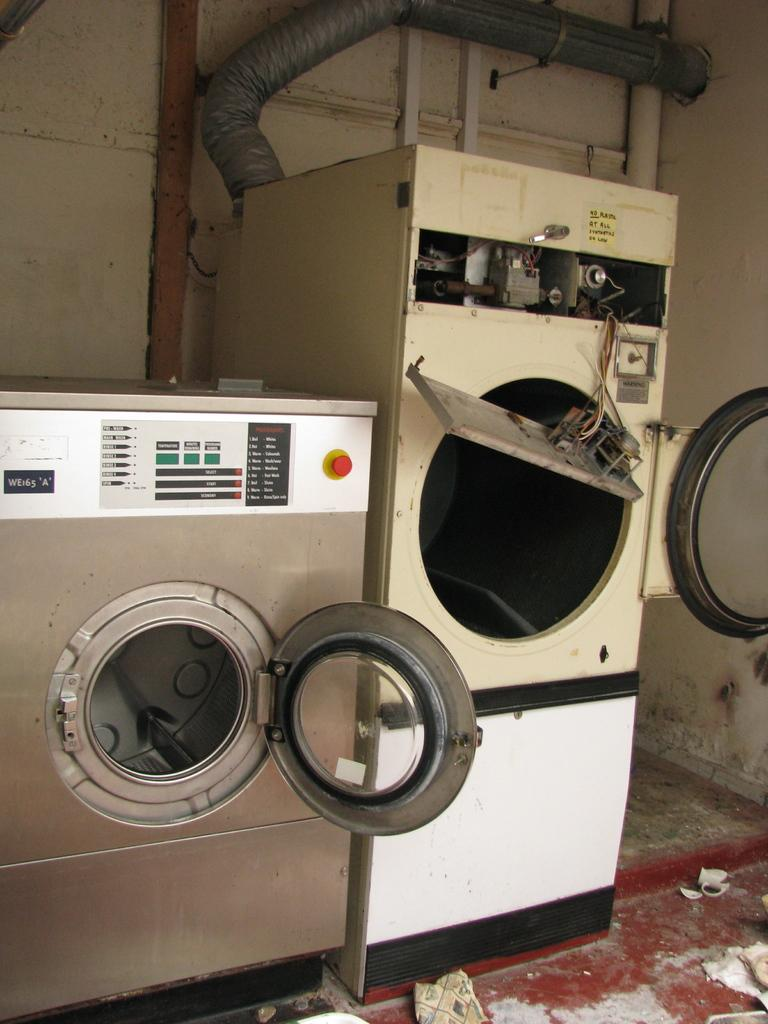What type of appliances can be seen in the image? There are two washing machines in the image. What is written on the washing machines? There is writing on the washing machines. What type of door is present on the washing machines in the image? There is no door present on the washing machines in the image; they are appliances without doors. 